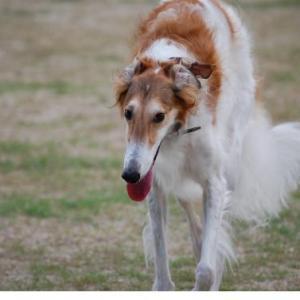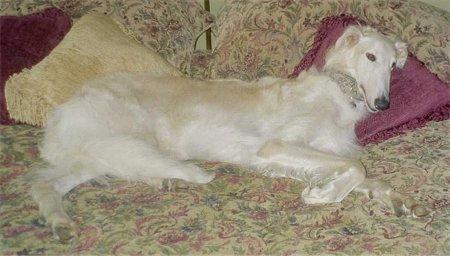The first image is the image on the left, the second image is the image on the right. Assess this claim about the two images: "A single dog is lying down in the image on the right.". Correct or not? Answer yes or no. Yes. The first image is the image on the left, the second image is the image on the right. Evaluate the accuracy of this statement regarding the images: "There are three dogs.". Is it true? Answer yes or no. No. 